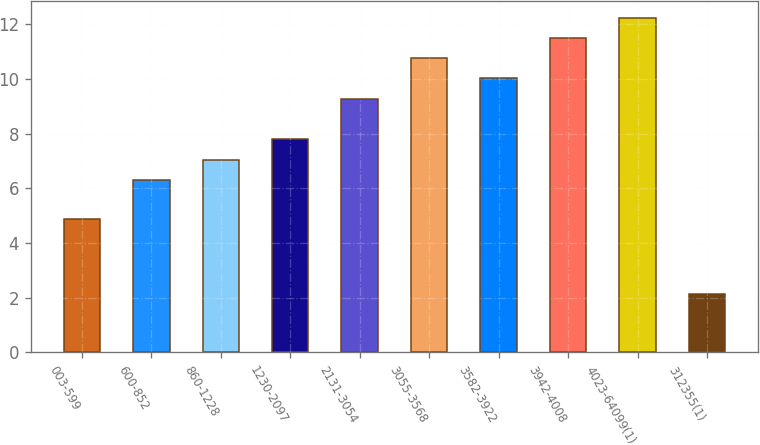Convert chart to OTSL. <chart><loc_0><loc_0><loc_500><loc_500><bar_chart><fcel>003-599<fcel>600-852<fcel>860-1228<fcel>1230-2097<fcel>2131-3054<fcel>3055-3568<fcel>3582-3922<fcel>3942-4008<fcel>4023-64099(1)<fcel>312355(1)<nl><fcel>4.89<fcel>6.3<fcel>7.04<fcel>7.79<fcel>9.28<fcel>10.76<fcel>10.02<fcel>11.5<fcel>12.24<fcel>2.15<nl></chart> 